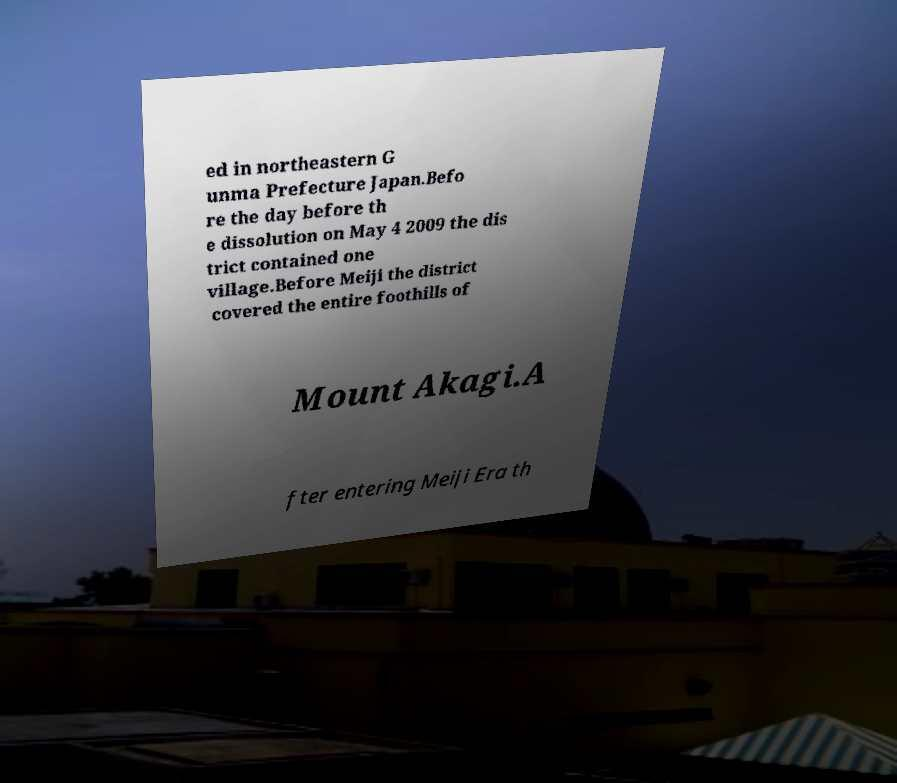Please read and relay the text visible in this image. What does it say? ed in northeastern G unma Prefecture Japan.Befo re the day before th e dissolution on May 4 2009 the dis trict contained one village.Before Meiji the district covered the entire foothills of Mount Akagi.A fter entering Meiji Era th 